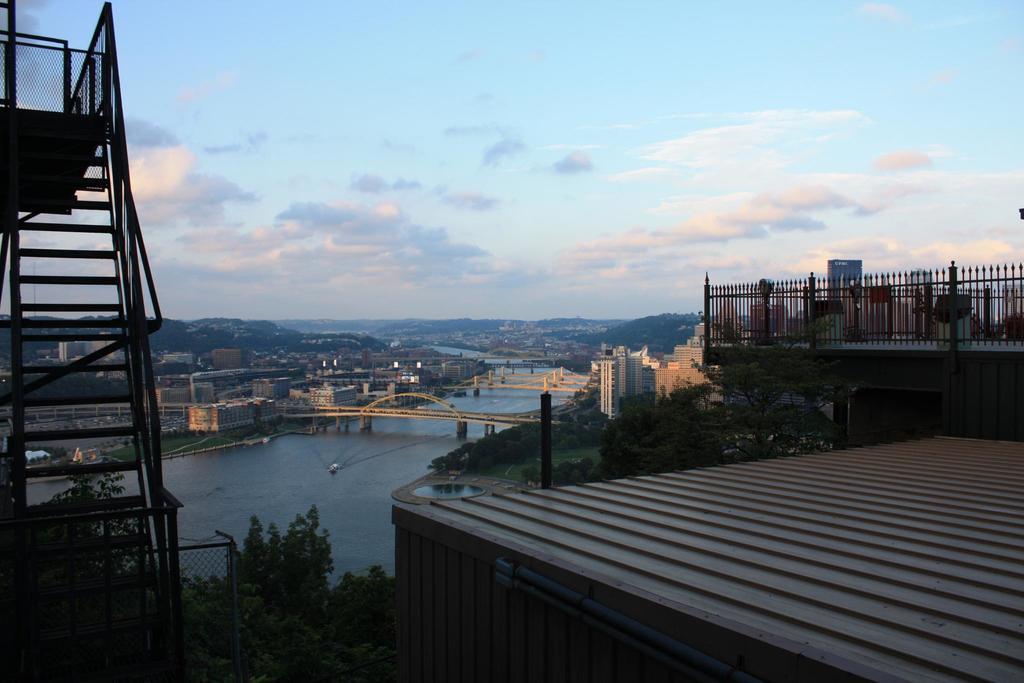Please provide a concise description of this image. In this image I can see few stairs at left, at back I can see poles, trees in green color, bridge, water. At top I can see sky in blue and white color. 